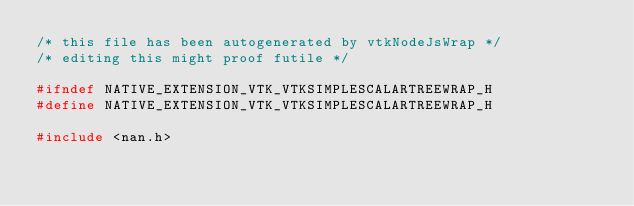<code> <loc_0><loc_0><loc_500><loc_500><_C_>/* this file has been autogenerated by vtkNodeJsWrap */
/* editing this might proof futile */

#ifndef NATIVE_EXTENSION_VTK_VTKSIMPLESCALARTREEWRAP_H
#define NATIVE_EXTENSION_VTK_VTKSIMPLESCALARTREEWRAP_H

#include <nan.h>
</code> 